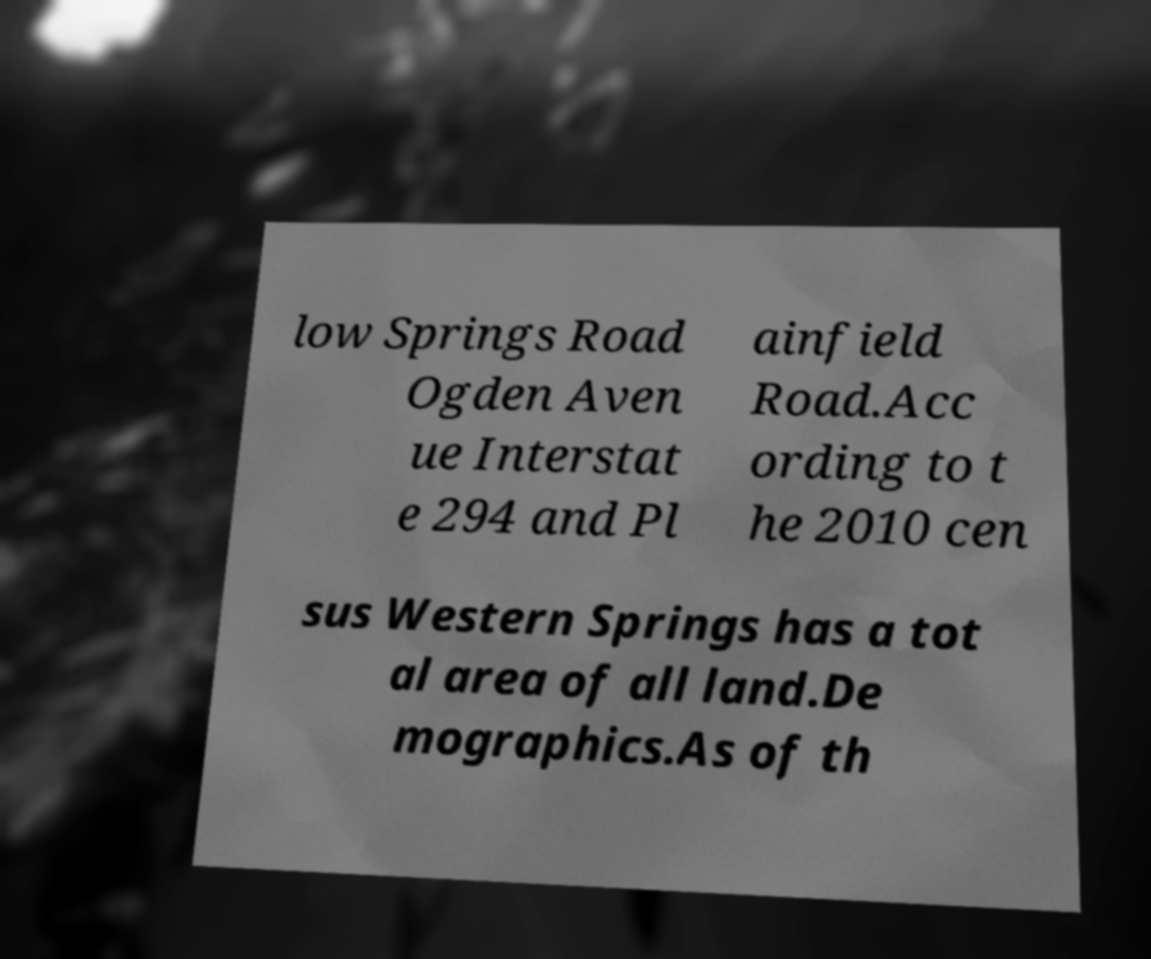There's text embedded in this image that I need extracted. Can you transcribe it verbatim? low Springs Road Ogden Aven ue Interstat e 294 and Pl ainfield Road.Acc ording to t he 2010 cen sus Western Springs has a tot al area of all land.De mographics.As of th 